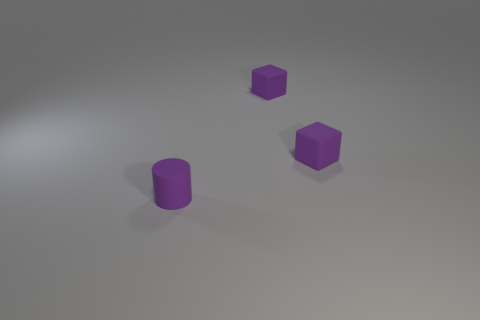Add 2 purple rubber cubes. How many objects exist? 5 Subtract all cyan cubes. How many blue cylinders are left? 0 Subtract all big metallic balls. Subtract all purple rubber cubes. How many objects are left? 1 Add 2 small matte cubes. How many small matte cubes are left? 4 Add 3 tiny cylinders. How many tiny cylinders exist? 4 Subtract 0 blue cubes. How many objects are left? 3 Subtract all blocks. How many objects are left? 1 Subtract all brown cubes. Subtract all blue cylinders. How many cubes are left? 2 